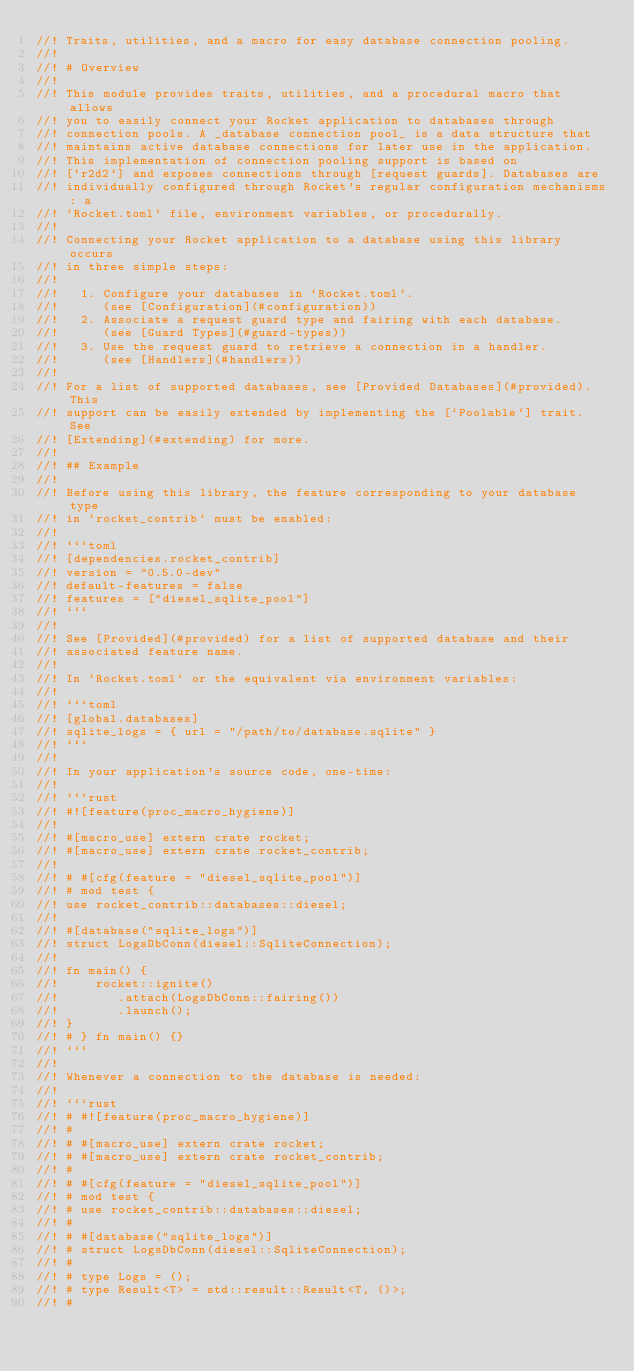<code> <loc_0><loc_0><loc_500><loc_500><_Rust_>//! Traits, utilities, and a macro for easy database connection pooling.
//!
//! # Overview
//!
//! This module provides traits, utilities, and a procedural macro that allows
//! you to easily connect your Rocket application to databases through
//! connection pools. A _database connection pool_ is a data structure that
//! maintains active database connections for later use in the application.
//! This implementation of connection pooling support is based on
//! [`r2d2`] and exposes connections through [request guards]. Databases are
//! individually configured through Rocket's regular configuration mechanisms: a
//! `Rocket.toml` file, environment variables, or procedurally.
//!
//! Connecting your Rocket application to a database using this library occurs
//! in three simple steps:
//!
//!   1. Configure your databases in `Rocket.toml`.
//!      (see [Configuration](#configuration))
//!   2. Associate a request guard type and fairing with each database.
//!      (see [Guard Types](#guard-types))
//!   3. Use the request guard to retrieve a connection in a handler.
//!      (see [Handlers](#handlers))
//!
//! For a list of supported databases, see [Provided Databases](#provided). This
//! support can be easily extended by implementing the [`Poolable`] trait. See
//! [Extending](#extending) for more.
//!
//! ## Example
//!
//! Before using this library, the feature corresponding to your database type
//! in `rocket_contrib` must be enabled:
//!
//! ```toml
//! [dependencies.rocket_contrib]
//! version = "0.5.0-dev"
//! default-features = false
//! features = ["diesel_sqlite_pool"]
//! ```
//!
//! See [Provided](#provided) for a list of supported database and their
//! associated feature name.
//!
//! In `Rocket.toml` or the equivalent via environment variables:
//!
//! ```toml
//! [global.databases]
//! sqlite_logs = { url = "/path/to/database.sqlite" }
//! ```
//!
//! In your application's source code, one-time:
//!
//! ```rust
//! #![feature(proc_macro_hygiene)]
//!
//! #[macro_use] extern crate rocket;
//! #[macro_use] extern crate rocket_contrib;
//!
//! # #[cfg(feature = "diesel_sqlite_pool")]
//! # mod test {
//! use rocket_contrib::databases::diesel;
//!
//! #[database("sqlite_logs")]
//! struct LogsDbConn(diesel::SqliteConnection);
//!
//! fn main() {
//!     rocket::ignite()
//!        .attach(LogsDbConn::fairing())
//!        .launch();
//! }
//! # } fn main() {}
//! ```
//!
//! Whenever a connection to the database is needed:
//!
//! ```rust
//! # #![feature(proc_macro_hygiene)]
//! #
//! # #[macro_use] extern crate rocket;
//! # #[macro_use] extern crate rocket_contrib;
//! #
//! # #[cfg(feature = "diesel_sqlite_pool")]
//! # mod test {
//! # use rocket_contrib::databases::diesel;
//! #
//! # #[database("sqlite_logs")]
//! # struct LogsDbConn(diesel::SqliteConnection);
//! #
//! # type Logs = ();
//! # type Result<T> = std::result::Result<T, ()>;
//! #</code> 